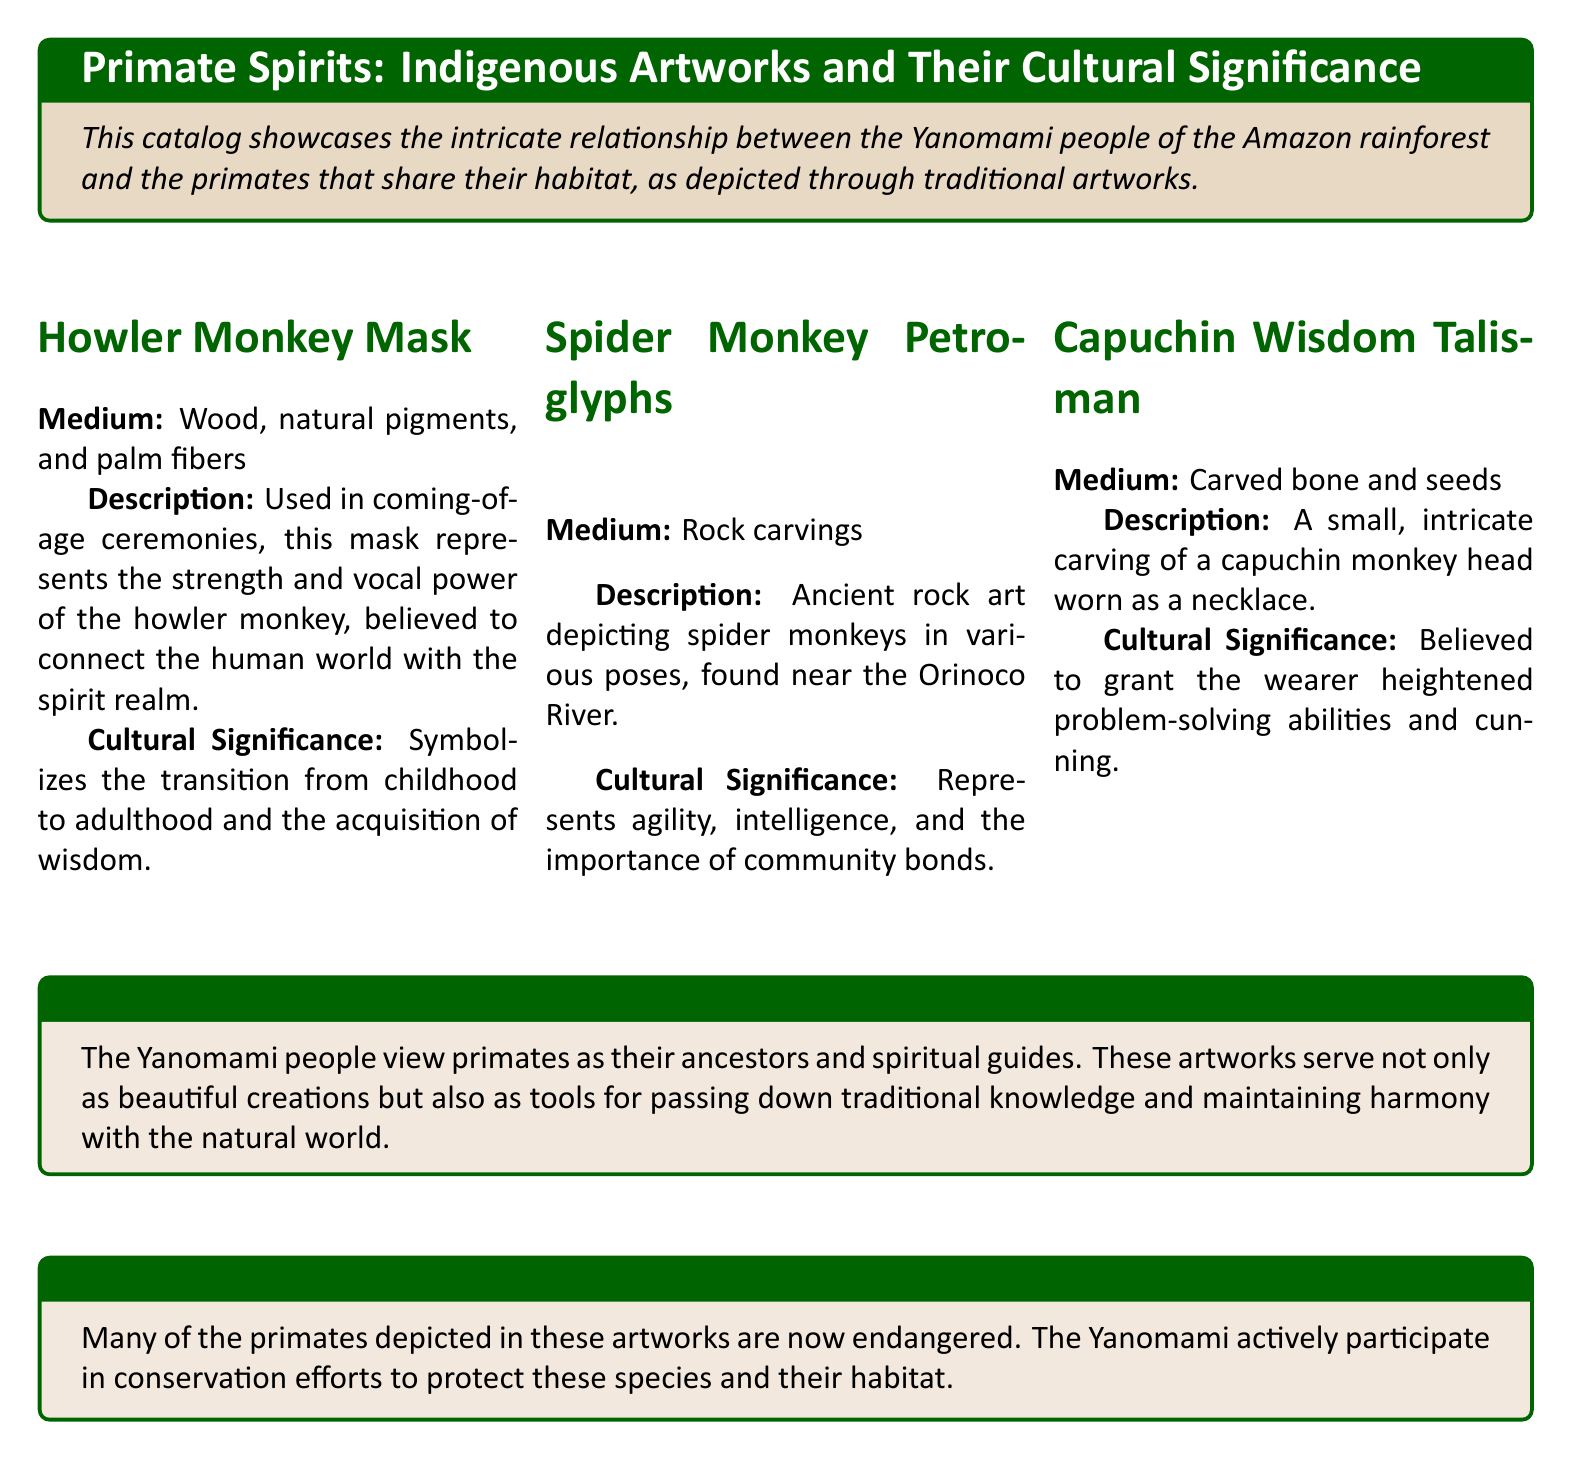What is the medium of the Howler Monkey Mask? The medium refers to the materials used to create the artwork, which are stated in the document as wood, natural pigments, and palm fibers.
Answer: Wood, natural pigments, and palm fibers What does the Howler Monkey Mask symbolize? The cultural significance section details that it symbolizes the transition from childhood to adulthood and the acquisition of wisdom.
Answer: Transition from childhood to adulthood Where were the Spider Monkey Petroglyphs found? The description states that they were found near the Orinoco River, indicating their geographical context.
Answer: Near the Orinoco River What ancient art form does the document mention? The document describes "rock carvings" as the ancient art form depicting primates, specifically the spider monkeys.
Answer: Rock carvings What type of talisman is associated with the Capuchin monkey? The document specifies that the Capuchin Wisdom Talisman is a small, intricate carving worn as a necklace.
Answer: Capuchin Wisdom Talisman Why do the Yanomami view primates as significant? The cultural context reveals that they view them as ancestors and spiritual guides, serving a dual purpose of art and knowledge sharing.
Answer: Ancestors and spiritual guides What is the primary concern mentioned in the Conservation Note? The document emphasizes the endangered status of many depicted primate species, resulting in a conservation concern.
Answer: Endangered What is the primary purpose of the artworks according to the cultural context? The document states that these artworks are tools for passing down traditional knowledge and maintaining harmony with the natural world.
Answer: Passing down traditional knowledge What type of medium is used for the Spider Monkey Petroglyphs? The document specifies that the medium used for the spider monkey representations is rock.
Answer: Rock 